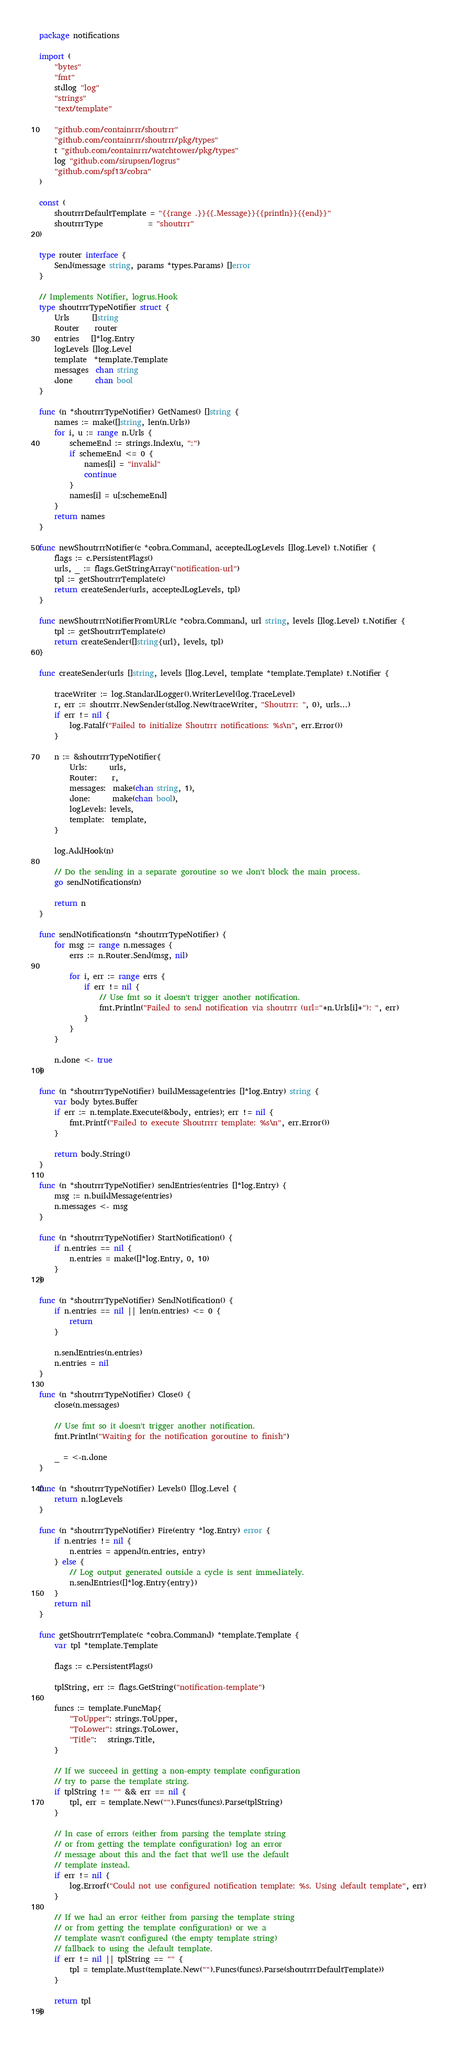Convert code to text. <code><loc_0><loc_0><loc_500><loc_500><_Go_>package notifications

import (
	"bytes"
	"fmt"
	stdlog "log"
	"strings"
	"text/template"

	"github.com/containrrr/shoutrrr"
	"github.com/containrrr/shoutrrr/pkg/types"
	t "github.com/containrrr/watchtower/pkg/types"
	log "github.com/sirupsen/logrus"
	"github.com/spf13/cobra"
)

const (
	shoutrrrDefaultTemplate = "{{range .}}{{.Message}}{{println}}{{end}}"
	shoutrrrType            = "shoutrrr"
)

type router interface {
	Send(message string, params *types.Params) []error
}

// Implements Notifier, logrus.Hook
type shoutrrrTypeNotifier struct {
	Urls      []string
	Router    router
	entries   []*log.Entry
	logLevels []log.Level
	template  *template.Template
	messages  chan string
	done      chan bool
}

func (n *shoutrrrTypeNotifier) GetNames() []string {
	names := make([]string, len(n.Urls))
	for i, u := range n.Urls {
		schemeEnd := strings.Index(u, ":")
		if schemeEnd <= 0 {
			names[i] = "invalid"
			continue
		}
		names[i] = u[:schemeEnd]
	}
	return names
}

func newShoutrrrNotifier(c *cobra.Command, acceptedLogLevels []log.Level) t.Notifier {
	flags := c.PersistentFlags()
	urls, _ := flags.GetStringArray("notification-url")
	tpl := getShoutrrrTemplate(c)
	return createSender(urls, acceptedLogLevels, tpl)
}

func newShoutrrrNotifierFromURL(c *cobra.Command, url string, levels []log.Level) t.Notifier {
	tpl := getShoutrrrTemplate(c)
	return createSender([]string{url}, levels, tpl)
}

func createSender(urls []string, levels []log.Level, template *template.Template) t.Notifier {

	traceWriter := log.StandardLogger().WriterLevel(log.TraceLevel)
	r, err := shoutrrr.NewSender(stdlog.New(traceWriter, "Shoutrrr: ", 0), urls...)
	if err != nil {
		log.Fatalf("Failed to initialize Shoutrrr notifications: %s\n", err.Error())
	}

	n := &shoutrrrTypeNotifier{
		Urls:      urls,
		Router:    r,
		messages:  make(chan string, 1),
		done:      make(chan bool),
		logLevels: levels,
		template:  template,
	}

	log.AddHook(n)

	// Do the sending in a separate goroutine so we don't block the main process.
	go sendNotifications(n)

	return n
}

func sendNotifications(n *shoutrrrTypeNotifier) {
	for msg := range n.messages {
		errs := n.Router.Send(msg, nil)

		for i, err := range errs {
			if err != nil {
				// Use fmt so it doesn't trigger another notification.
				fmt.Println("Failed to send notification via shoutrrr (url="+n.Urls[i]+"): ", err)
			}
		}
	}

	n.done <- true
}

func (n *shoutrrrTypeNotifier) buildMessage(entries []*log.Entry) string {
	var body bytes.Buffer
	if err := n.template.Execute(&body, entries); err != nil {
		fmt.Printf("Failed to execute Shoutrrrr template: %s\n", err.Error())
	}

	return body.String()
}

func (n *shoutrrrTypeNotifier) sendEntries(entries []*log.Entry) {
	msg := n.buildMessage(entries)
	n.messages <- msg
}

func (n *shoutrrrTypeNotifier) StartNotification() {
	if n.entries == nil {
		n.entries = make([]*log.Entry, 0, 10)
	}
}

func (n *shoutrrrTypeNotifier) SendNotification() {
	if n.entries == nil || len(n.entries) <= 0 {
		return
	}

	n.sendEntries(n.entries)
	n.entries = nil
}

func (n *shoutrrrTypeNotifier) Close() {
	close(n.messages)

	// Use fmt so it doesn't trigger another notification.
	fmt.Println("Waiting for the notification goroutine to finish")

	_ = <-n.done
}

func (n *shoutrrrTypeNotifier) Levels() []log.Level {
	return n.logLevels
}

func (n *shoutrrrTypeNotifier) Fire(entry *log.Entry) error {
	if n.entries != nil {
		n.entries = append(n.entries, entry)
	} else {
		// Log output generated outside a cycle is sent immediately.
		n.sendEntries([]*log.Entry{entry})
	}
	return nil
}

func getShoutrrrTemplate(c *cobra.Command) *template.Template {
	var tpl *template.Template

	flags := c.PersistentFlags()

	tplString, err := flags.GetString("notification-template")

	funcs := template.FuncMap{
		"ToUpper": strings.ToUpper,
		"ToLower": strings.ToLower,
		"Title":   strings.Title,
	}

	// If we succeed in getting a non-empty template configuration
	// try to parse the template string.
	if tplString != "" && err == nil {
		tpl, err = template.New("").Funcs(funcs).Parse(tplString)
	}

	// In case of errors (either from parsing the template string
	// or from getting the template configuration) log an error
	// message about this and the fact that we'll use the default
	// template instead.
	if err != nil {
		log.Errorf("Could not use configured notification template: %s. Using default template", err)
	}

	// If we had an error (either from parsing the template string
	// or from getting the template configuration) or we a
	// template wasn't configured (the empty template string)
	// fallback to using the default template.
	if err != nil || tplString == "" {
		tpl = template.Must(template.New("").Funcs(funcs).Parse(shoutrrrDefaultTemplate))
	}

	return tpl
}
</code> 